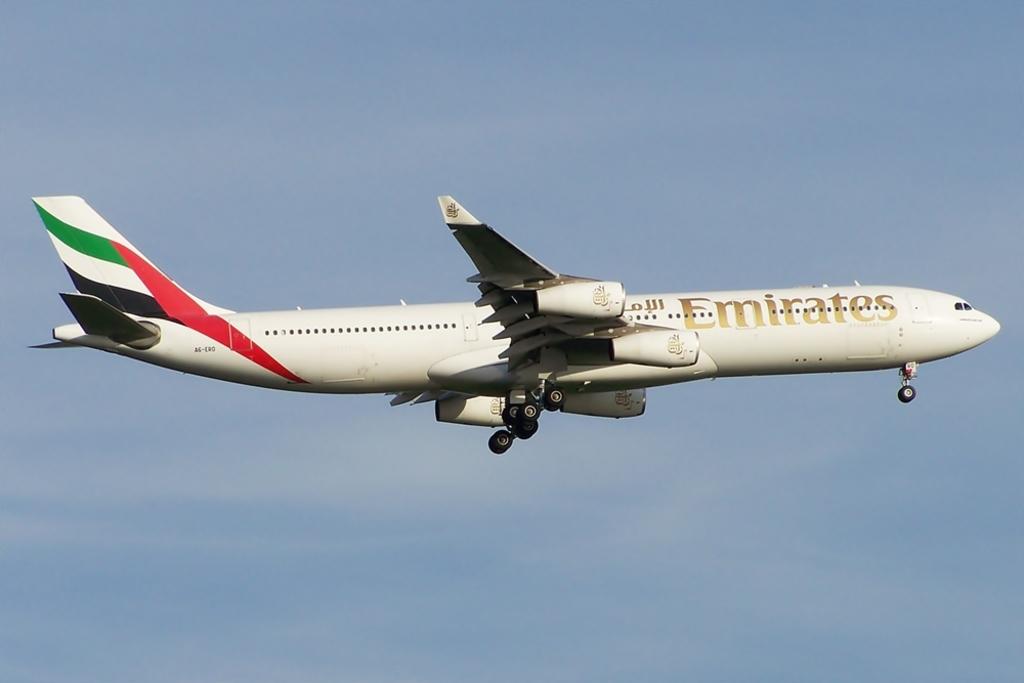Who owns this plane?
Provide a short and direct response. Emirates. 